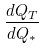<formula> <loc_0><loc_0><loc_500><loc_500>\frac { d Q _ { T } } { d Q _ { * } }</formula> 